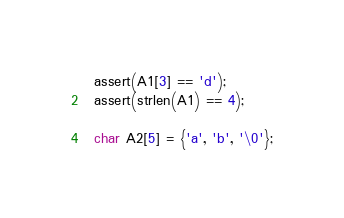<code> <loc_0><loc_0><loc_500><loc_500><_C_>  assert(A1[3] == 'd');
  assert(strlen(A1) == 4);

  char A2[5] = {'a', 'b', '\0'};</code> 